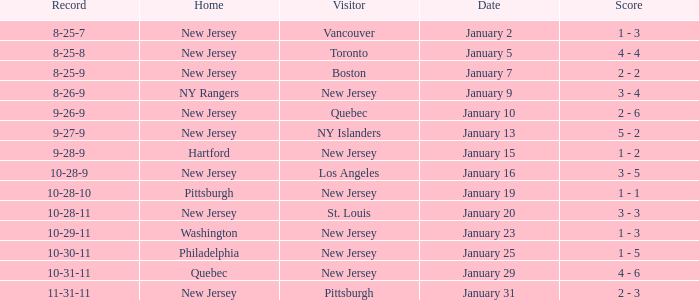What was the date that ended in a record of 8-25-7? January 2. 